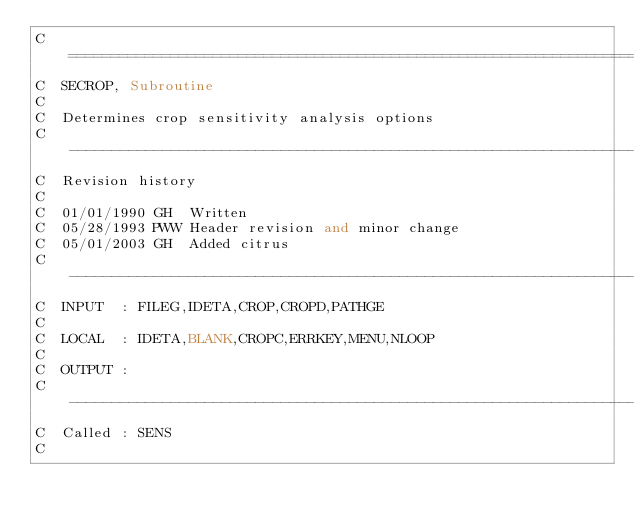<code> <loc_0><loc_0><loc_500><loc_500><_FORTRAN_>C=======================================================================
C  SECROP, Subroutine
C
C  Determines crop sensitivity analysis options
C-----------------------------------------------------------------------
C  Revision history
C
C  01/01/1990 GH  Written
C  05/28/1993 PWW Header revision and minor change
C  05/01/2003 GH  Added citrus
C-----------------------------------------------------------------------
C  INPUT  : FILEG,IDETA,CROP,CROPD,PATHGE
C
C  LOCAL  : IDETA,BLANK,CROPC,ERRKEY,MENU,NLOOP
C
C  OUTPUT :
C-----------------------------------------------------------------------
C  Called : SENS
C</code> 